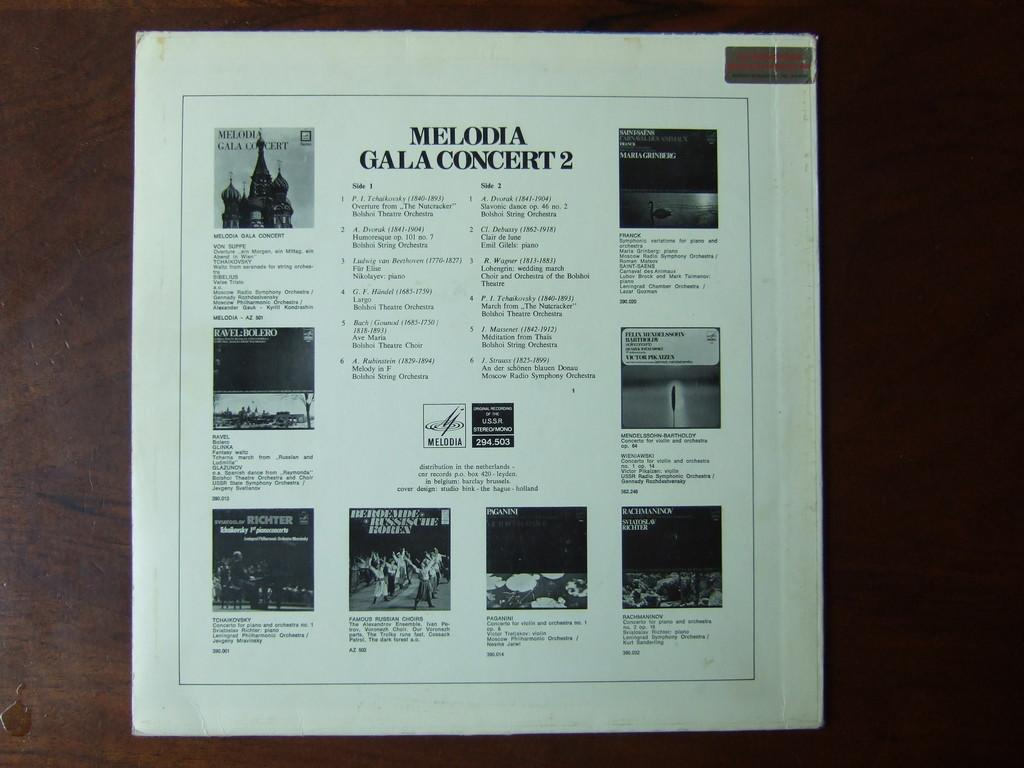<image>
Summarize the visual content of the image. A brochure which has a title of Melodia Gala Concert 2 with pictures on both sides and the bottom of the brochure. 